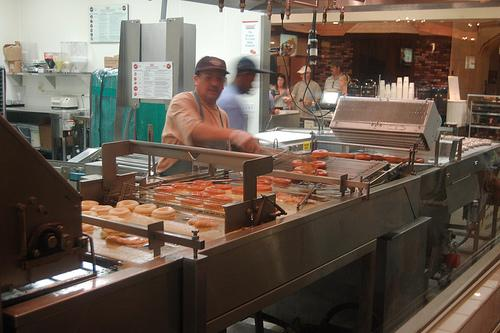Describe any interesting details about the objects surrounding the man in the picture. The surrounding objects include stacks of white cups, doughnuts traveling down a conveyor belt, an electrical wire attached to a doughnut machine, a rack of silver trays, and various signs on the walls. Discuss the role of the customers in the background of this image. The customers in the background are eagerly waiting for their orders, showing the popularity of the doughnut shop and creating a lively atmosphere. How does the image portray a story of a person working in a bakery? The image shows a man wearing an apron and gloves, making doughnuts on a conveyor belt, with customers present in the background and various bakery-related items around him. Mention the focal point of the image and its characteristics. The focal point is a man wearing a white shirt and blue apron, who is working at a doughnut conveyor belt, with an attentive posture and wearing gloves. Create a detailed description of the man's attire in the image. The man is wearing a white shirt with short sleeves, a blue apron, glasses, and white gloves, while engaging in the task of making doughnuts. In your own words, describe the atmosphere and setting of the image. The image is set in a busy doughnut shop with stacks of doughnuts, an attentive baker, and happy customers waiting for their orders in a clean and well-organized environment. Mention some of the important activities happening in the image. A man is making doughnuts, customers are making orders, doughnuts are traveling down a conveyor belt, and various other bakery items can be observed in the well-organized doughnut shop. Narrate the scene presented in the image. A man wearing glasses and an apron is making doughnuts at a conveyor belt, while customers wait in the background and rows of doughnuts travel down the belt. Write a brief summary of what you can observe in the picture. A picture illustrating a man working diligently on making doughnuts as they travel down a conveyor belt, while customers in the background make their orders and various other bakery items can be seen around. Enumerate some of the prominent objects found in the image along with their captions. Man wearing glasses, doughnuts on a tray, a white wall, entrance made of bricks, people in the background, stacks of white cups, and lights on the ceiling. 